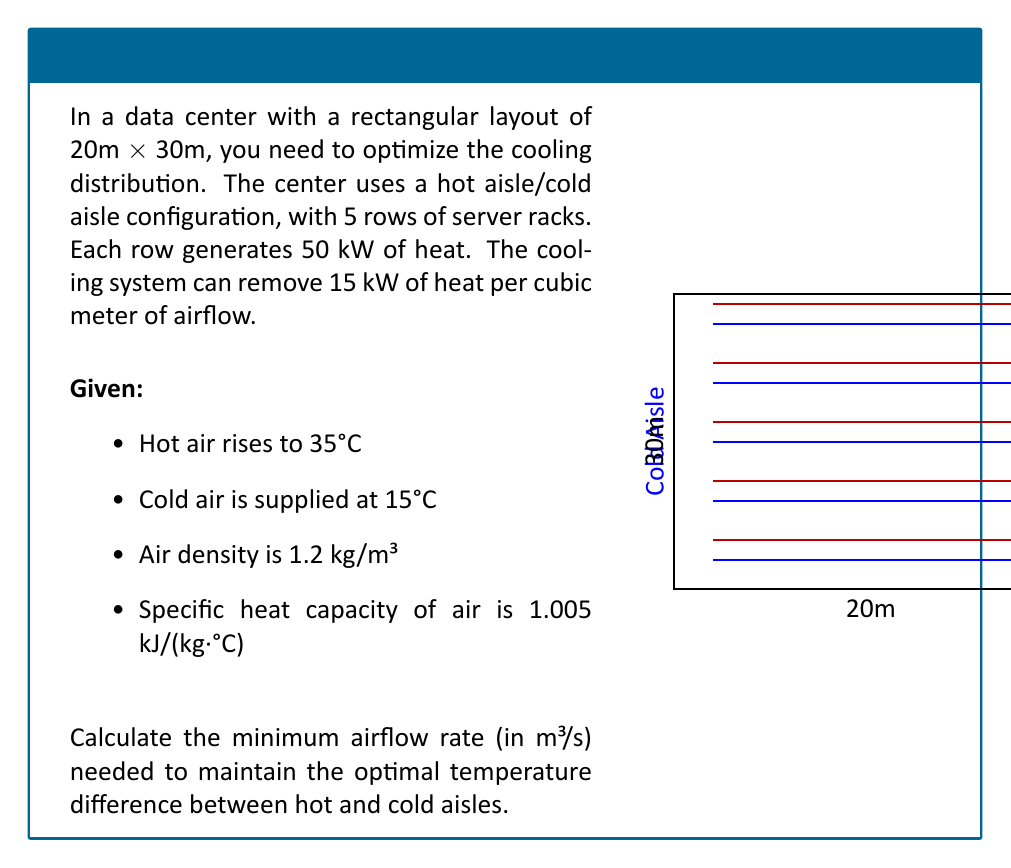Teach me how to tackle this problem. To solve this problem, we'll follow these steps:

1) Calculate the total heat generated:
   Total heat = 5 rows × 50 kW/row = 250 kW

2) Calculate the temperature difference:
   ΔT = Hot air temperature - Cold air temperature
      = 35°C - 15°C = 20°C

3) Use the heat transfer equation:
   $Q = \dot{m} \cdot c_p \cdot \Delta T$
   Where:
   Q = heat transfer rate (250 kW = 250,000 J/s)
   $\dot{m}$ = mass flow rate (kg/s)
   $c_p$ = specific heat capacity (1.005 kJ/(kg·°C))
   ΔT = temperature difference (20°C)

4) Rearrange the equation to solve for $\dot{m}$:
   $\dot{m} = \frac{Q}{c_p \cdot \Delta T}$

5) Substitute the values:
   $\dot{m} = \frac{250,000}{1.005 \cdot 20} = 12,437.81$ kg/s

6) Convert mass flow rate to volumetric flow rate:
   $\dot{V} = \frac{\dot{m}}{\rho}$
   Where $\rho$ is the air density (1.2 kg/m³)

   $\dot{V} = \frac{12,437.81}{1.2} = 10,364.84$ m³/s

7) Check if this meets the cooling system capacity:
   Required cooling capacity = 10,364.84 m³/s × 15 kW/m³ = 155,472.6 kW
   This exceeds the total heat generated (250 kW), so it's sufficient.

Therefore, the minimum airflow rate needed is 10,364.84 m³/s.
Answer: 10,364.84 m³/s 